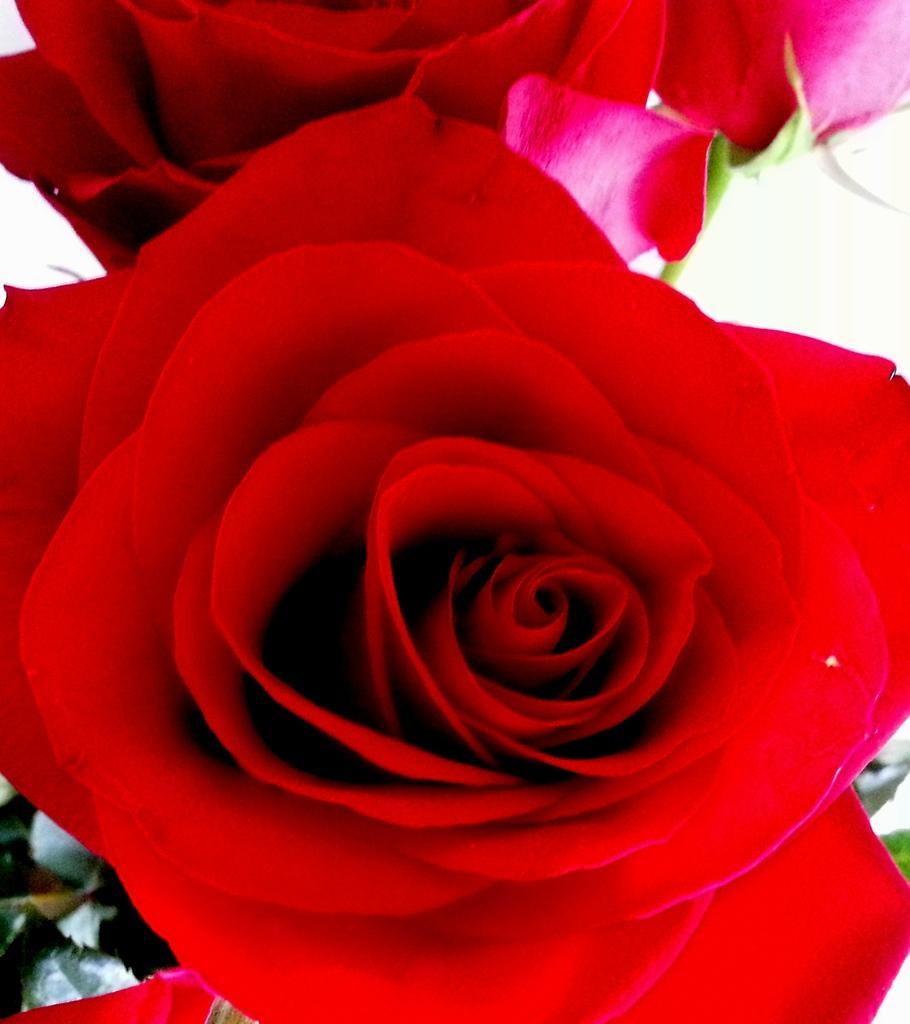Can you describe this image briefly? In this image I can see two red roses. The background is in white color. In the bottom left-hand corner few leaves are visible. 